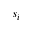<formula> <loc_0><loc_0><loc_500><loc_500>s _ { i }</formula> 